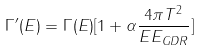Convert formula to latex. <formula><loc_0><loc_0><loc_500><loc_500>\Gamma ^ { \prime } ( E ) = \Gamma ( E ) [ 1 + \alpha \frac { 4 \pi T ^ { 2 } } { E E _ { G D R } } ]</formula> 